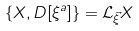<formula> <loc_0><loc_0><loc_500><loc_500>\left \{ X , D [ \xi ^ { a } ] \right \} = { \mathcal { L } _ { \vec { \xi } } X }</formula> 